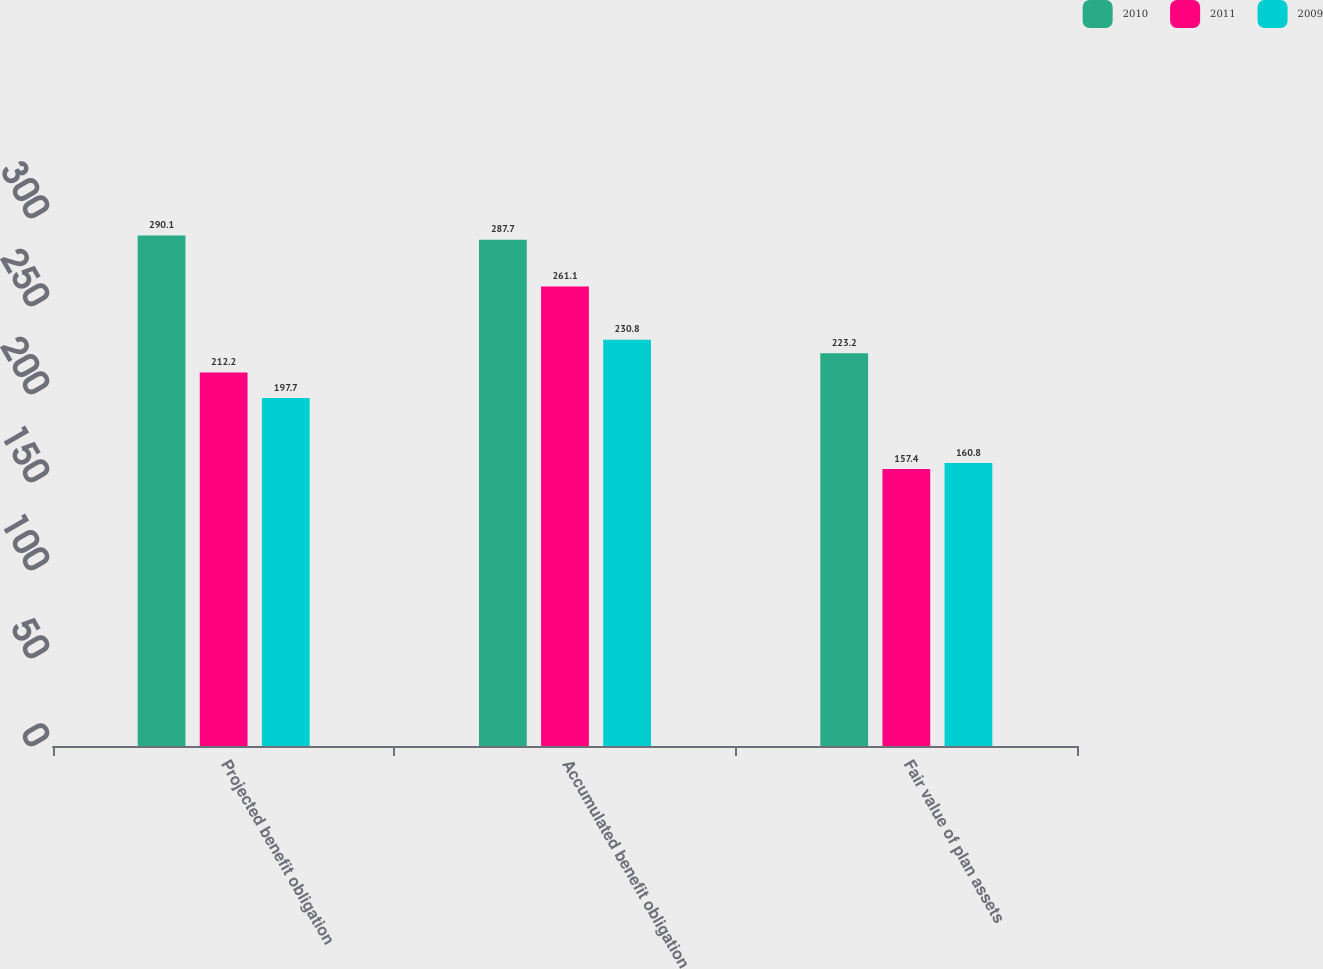Convert chart. <chart><loc_0><loc_0><loc_500><loc_500><stacked_bar_chart><ecel><fcel>Projected benefit obligation<fcel>Accumulated benefit obligation<fcel>Fair value of plan assets<nl><fcel>2010<fcel>290.1<fcel>287.7<fcel>223.2<nl><fcel>2011<fcel>212.2<fcel>261.1<fcel>157.4<nl><fcel>2009<fcel>197.7<fcel>230.8<fcel>160.8<nl></chart> 